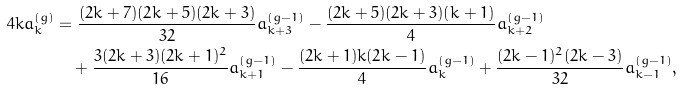Convert formula to latex. <formula><loc_0><loc_0><loc_500><loc_500>4 k a _ { k } ^ { ( g ) } = & \ \frac { ( 2 k + 7 ) ( 2 k + 5 ) ( 2 k + 3 ) } { 3 2 } a _ { k + 3 } ^ { ( g - 1 ) } - \frac { ( 2 k + 5 ) ( 2 k + 3 ) ( k + 1 ) } { 4 } a _ { k + 2 } ^ { ( g - 1 ) } \\ & + \frac { 3 ( 2 k + 3 ) ( 2 k + 1 ) ^ { 2 } } { 1 6 } a _ { k + 1 } ^ { ( g - 1 ) } - \frac { ( 2 k + 1 ) k ( 2 k - 1 ) } { 4 } a _ { k } ^ { ( g - 1 ) } + \frac { ( 2 k - 1 ) ^ { 2 } ( 2 k - 3 ) } { 3 2 } a _ { k - 1 } ^ { ( g - 1 ) } ,</formula> 